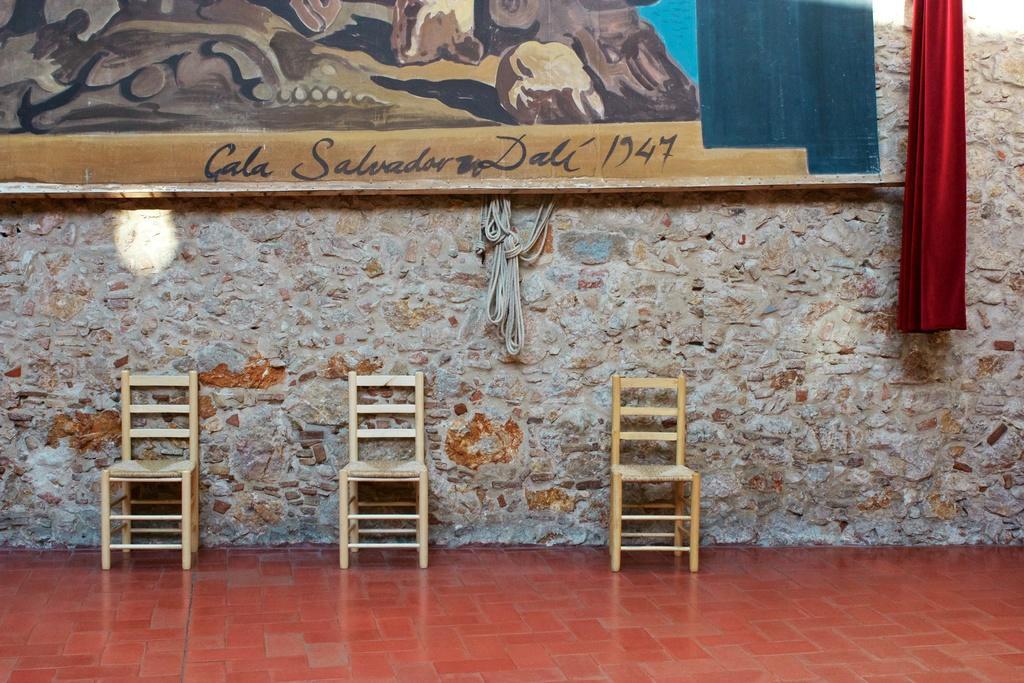<image>
Describe the image concisely. Three wooden chairs are on a red tile floor under a painting dated 1947. 